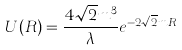Convert formula to latex. <formula><loc_0><loc_0><loc_500><loc_500>U ( R ) = \frac { 4 \sqrt { 2 } m ^ { 3 } } { \lambda } e ^ { - 2 \sqrt { 2 } m R }</formula> 